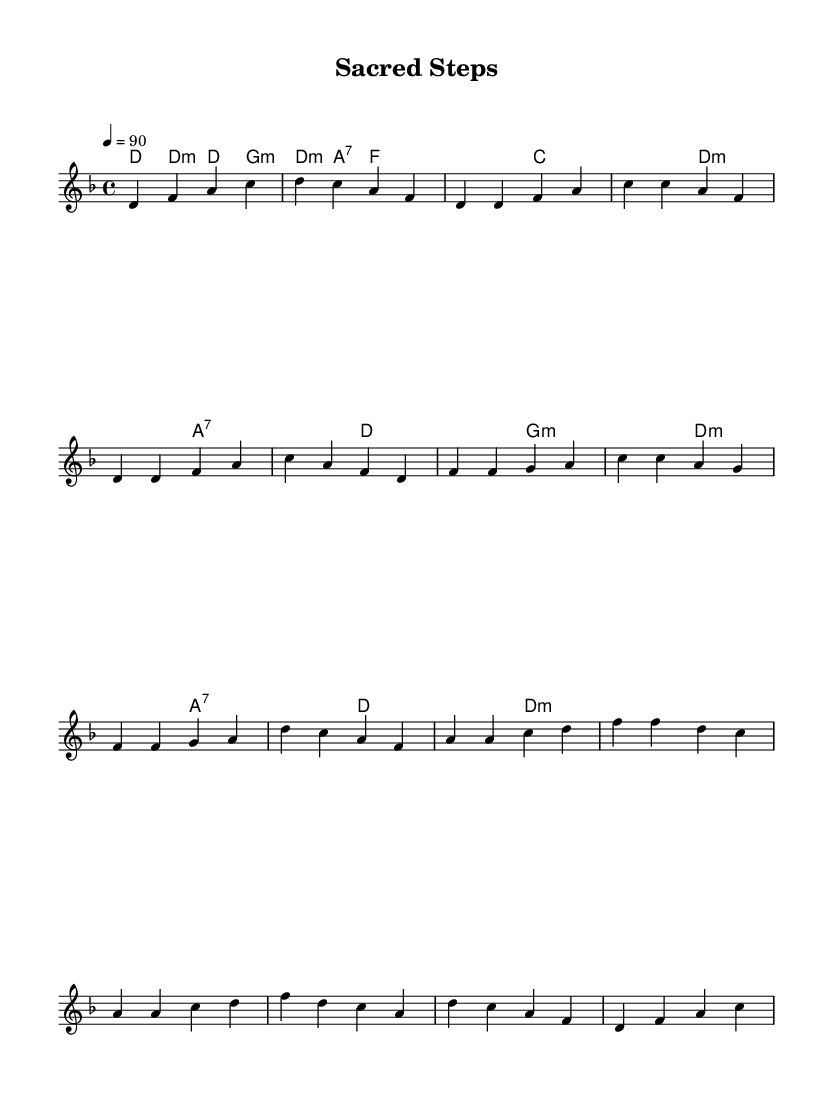What is the key signature of this music? The key signature indicated is D minor, which has one flat (B flat). This is evident from the musical notation shown at the beginning of the sheet music.
Answer: D minor What is the time signature of this piece? The time signature is 4/4, which means there are four beats in each measure and a quarter note gets one beat. This can be seen written at the beginning of the score.
Answer: 4/4 What is the tempo marking for this music? The tempo marking is 90 beats per minute, indicated in the score as "4 = 90." This shows the speed at which the piece should be played.
Answer: 90 What is the first chord of the song? The first chord, as indicated in the harmonies section, is a D minor chord, noted as "d:m1." This shows the harmonic foundation at the start of the piece.
Answer: D minor How many measures are in the chorus? The chorus consists of four measures, as can be counted in the section that repeats the chorus motif. Each grouped line shows individual measures within that section.
Answer: 4 What musical form does this piece exhibit? This piece is structured in a verse-chorus format, as evidenced by the distinct sections labeled "Verse 1" and "Chorus," which alternate throughout the composition.
Answer: Verse-Chorus What is the role of the bridge in this composition? The bridge serves as a contrasting section that leads the listener from the chorus back to the verse or outro, providing variation and a break from repetition, which is common in rap music.
Answer: Contrast 